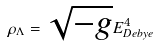<formula> <loc_0><loc_0><loc_500><loc_500>\rho _ { \Lambda } = \sqrt { - g } E ^ { 4 } _ { D e b y e }</formula> 